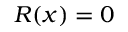<formula> <loc_0><loc_0><loc_500><loc_500>R ( x ) = 0</formula> 